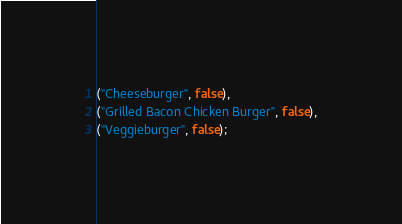Convert code to text. <code><loc_0><loc_0><loc_500><loc_500><_SQL_>("Cheeseburger", false),
("Grilled Bacon Chicken Burger", false),
("Veggieburger", false);</code> 